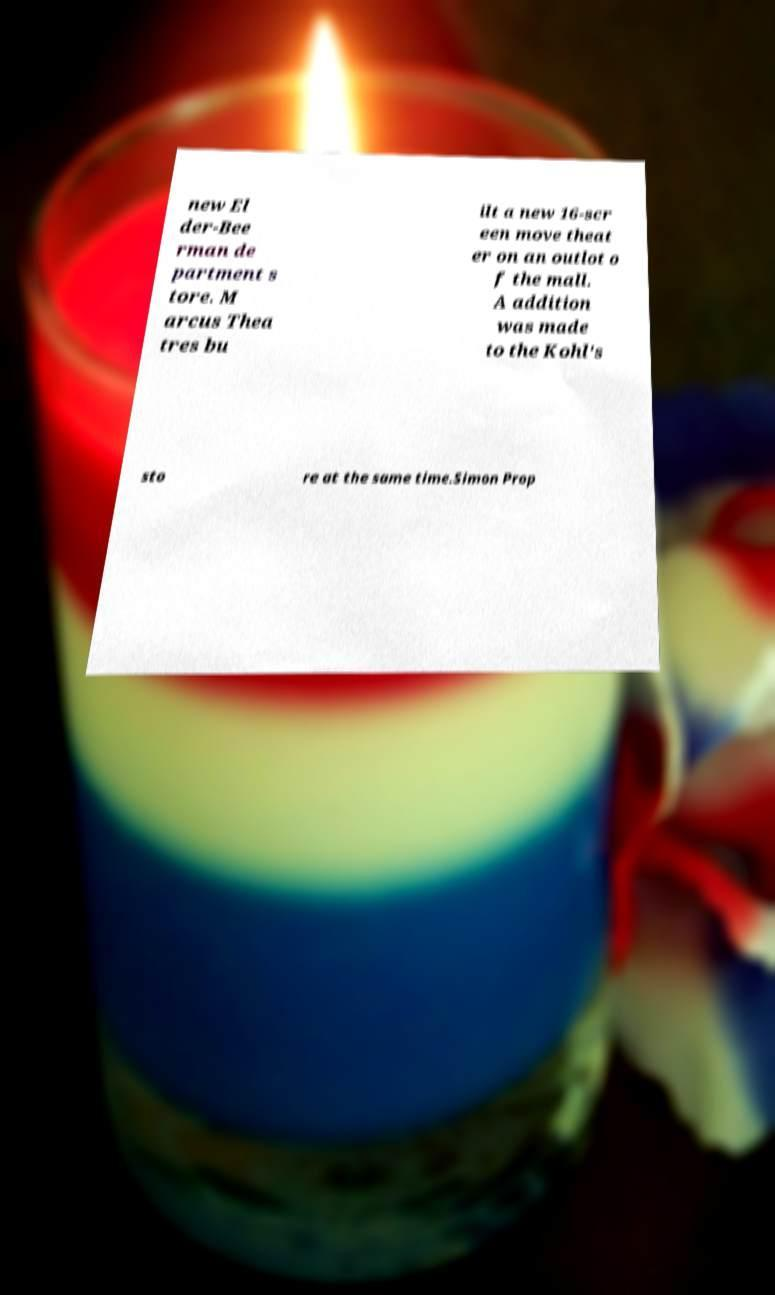Please read and relay the text visible in this image. What does it say? new El der-Bee rman de partment s tore. M arcus Thea tres bu ilt a new 16-scr een move theat er on an outlot o f the mall. A addition was made to the Kohl's sto re at the same time.Simon Prop 